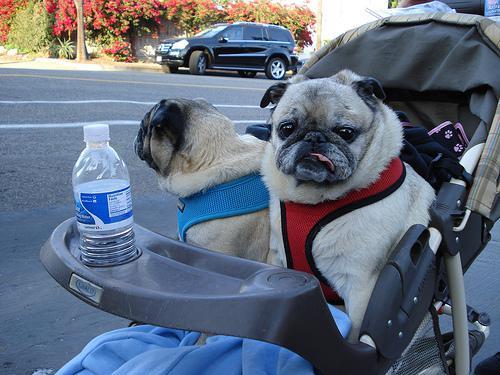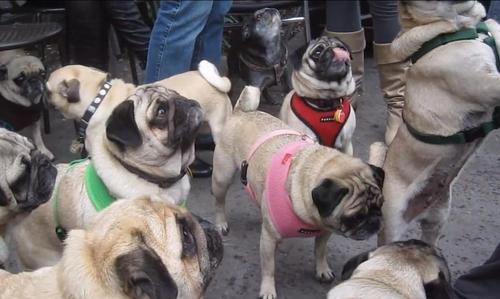The first image is the image on the left, the second image is the image on the right. Analyze the images presented: Is the assertion "At least one dog is sleeping." valid? Answer yes or no. No. The first image is the image on the left, the second image is the image on the right. For the images shown, is this caption "there are pugs with harnesses on" true? Answer yes or no. Yes. 